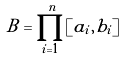<formula> <loc_0><loc_0><loc_500><loc_500>B = \prod _ { i = 1 } ^ { n } [ a _ { i } , b _ { i } ]</formula> 